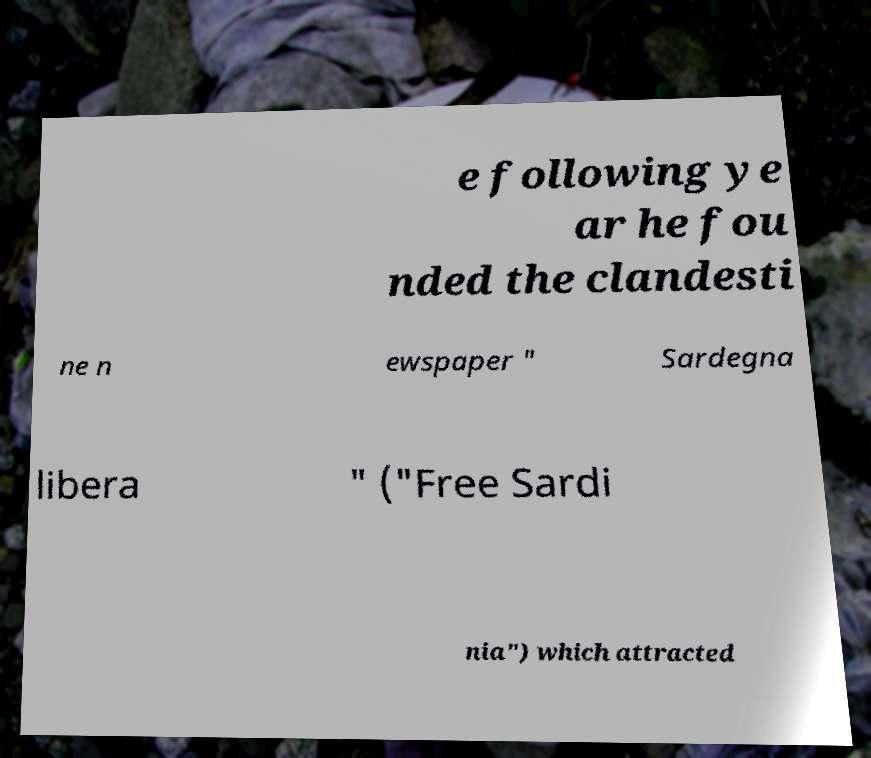Can you read and provide the text displayed in the image?This photo seems to have some interesting text. Can you extract and type it out for me? e following ye ar he fou nded the clandesti ne n ewspaper " Sardegna libera " ("Free Sardi nia") which attracted 